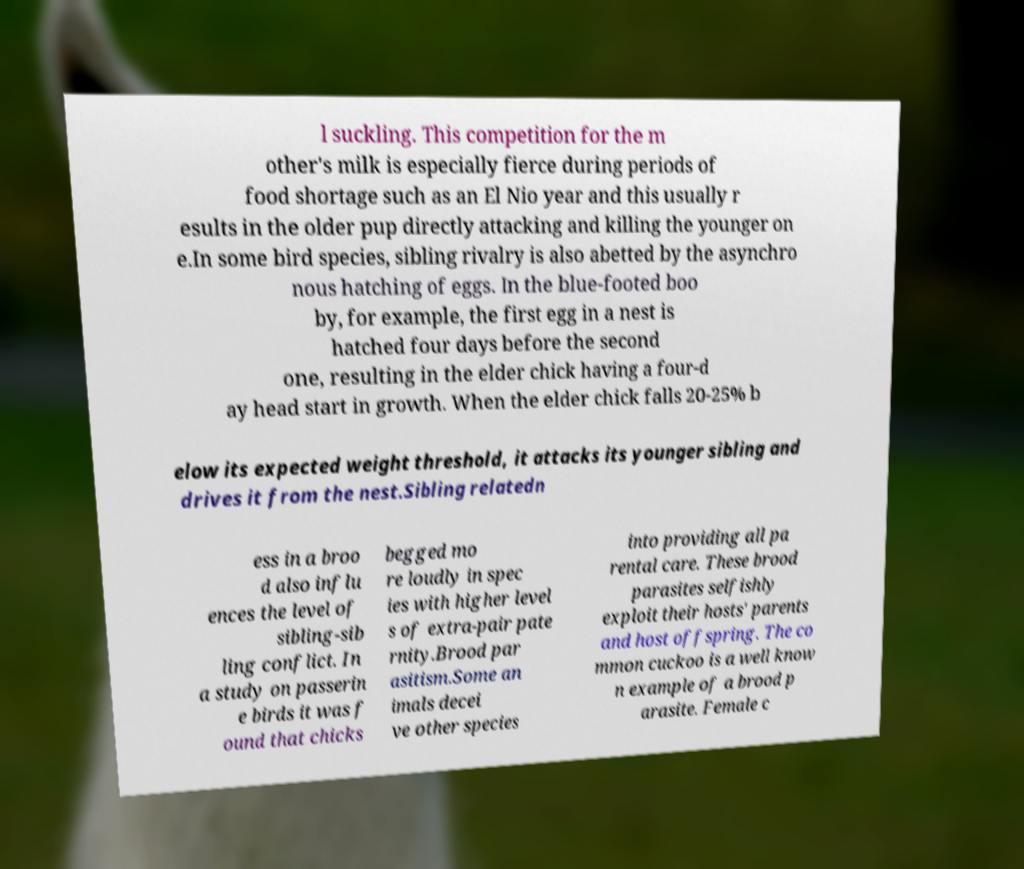What messages or text are displayed in this image? I need them in a readable, typed format. l suckling. This competition for the m other's milk is especially fierce during periods of food shortage such as an El Nio year and this usually r esults in the older pup directly attacking and killing the younger on e.In some bird species, sibling rivalry is also abetted by the asynchro nous hatching of eggs. In the blue-footed boo by, for example, the first egg in a nest is hatched four days before the second one, resulting in the elder chick having a four-d ay head start in growth. When the elder chick falls 20-25% b elow its expected weight threshold, it attacks its younger sibling and drives it from the nest.Sibling relatedn ess in a broo d also influ ences the level of sibling-sib ling conflict. In a study on passerin e birds it was f ound that chicks begged mo re loudly in spec ies with higher level s of extra-pair pate rnity.Brood par asitism.Some an imals decei ve other species into providing all pa rental care. These brood parasites selfishly exploit their hosts' parents and host offspring. The co mmon cuckoo is a well know n example of a brood p arasite. Female c 